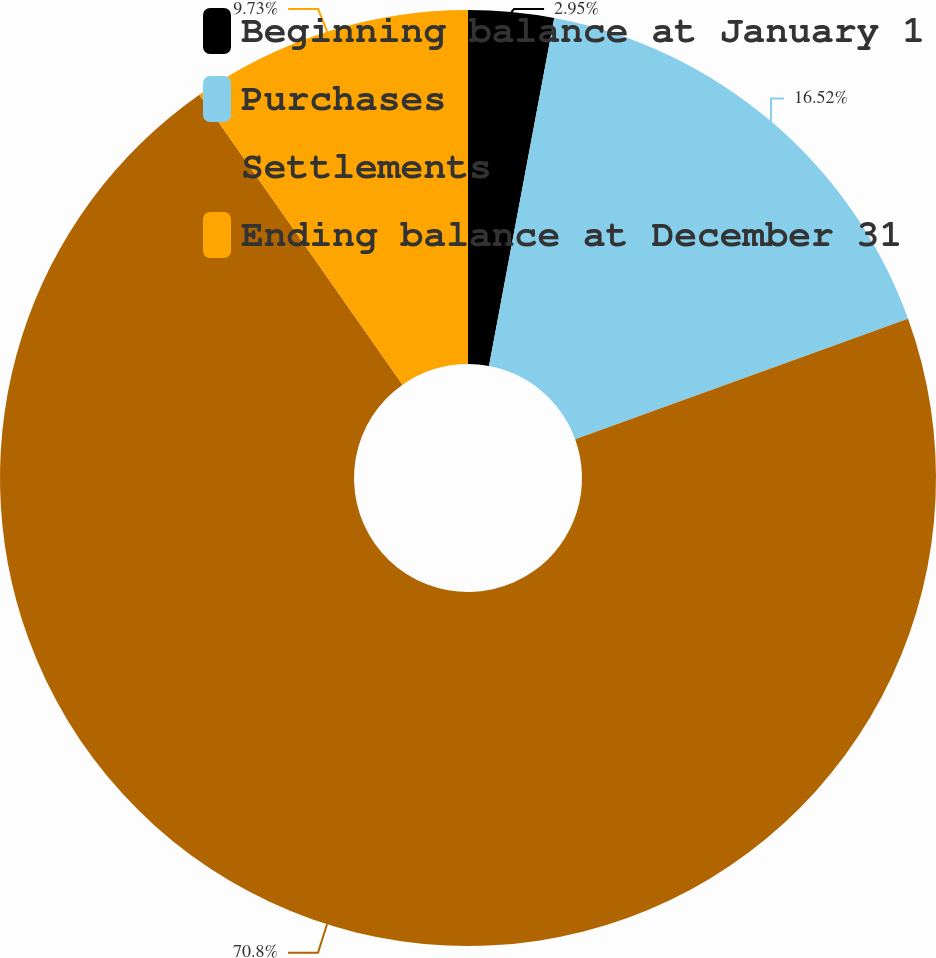Convert chart to OTSL. <chart><loc_0><loc_0><loc_500><loc_500><pie_chart><fcel>Beginning balance at January 1<fcel>Purchases<fcel>Settlements<fcel>Ending balance at December 31<nl><fcel>2.95%<fcel>16.52%<fcel>70.8%<fcel>9.73%<nl></chart> 